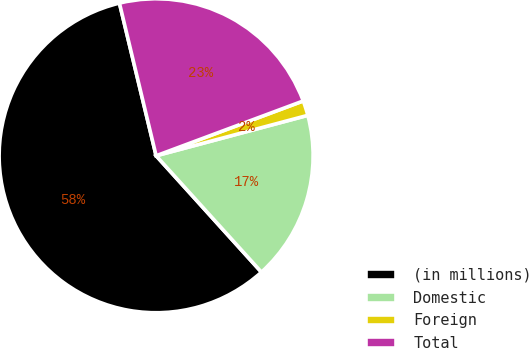Convert chart to OTSL. <chart><loc_0><loc_0><loc_500><loc_500><pie_chart><fcel>(in millions)<fcel>Domestic<fcel>Foreign<fcel>Total<nl><fcel>57.95%<fcel>17.44%<fcel>1.53%<fcel>23.08%<nl></chart> 